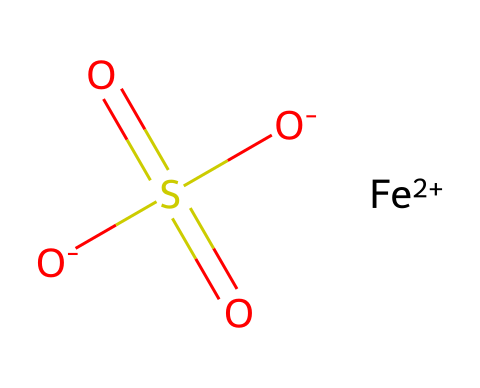What is the central metal atom in this compound? The SMILES representation contains the symbol "Fe," which stands for iron. Iron is the central metal atom combined with the other elements in the chemical structure.
Answer: iron How many sulfate groups are present in this molecule? The structure contains one sulfur atom connected to three oxygen atoms, indicating a sulfate group, specifically represented as "S(=O)(=O)[O-]". Since there's only one such group, the answer is one.
Answer: one What is the oxidation state of iron in this compound? The "[Fe+2]" notation in the SMILES indicates that the iron atom has a +2 oxidation state. This is crucial for understanding its reactivity and role in enhancing crop nutrient uptake.
Answer: +2 What type of chemical structure is represented? This compound is an organometallic complex involving a metal, iron, and an associated ligand, which in this case is a sulfate ion. This categorization enables it to interact effectively with biological systems in crops.
Answer: organometallic What role does the sulfate ion play in this chemical structure? The sulfate ion is a common nutrient for plants, providing sulfur, which is essential for various metabolic processes. Thus, it enhances the overall nutrient profile offered to the crops.
Answer: nutrient How many oxygen atoms are present in this compound? From the structure, there are a total of four oxygen atoms visible: three from the sulfate group and one additional oxygen with a negative charge. Therefore, adding these up gives you four oxygen atoms.
Answer: four 